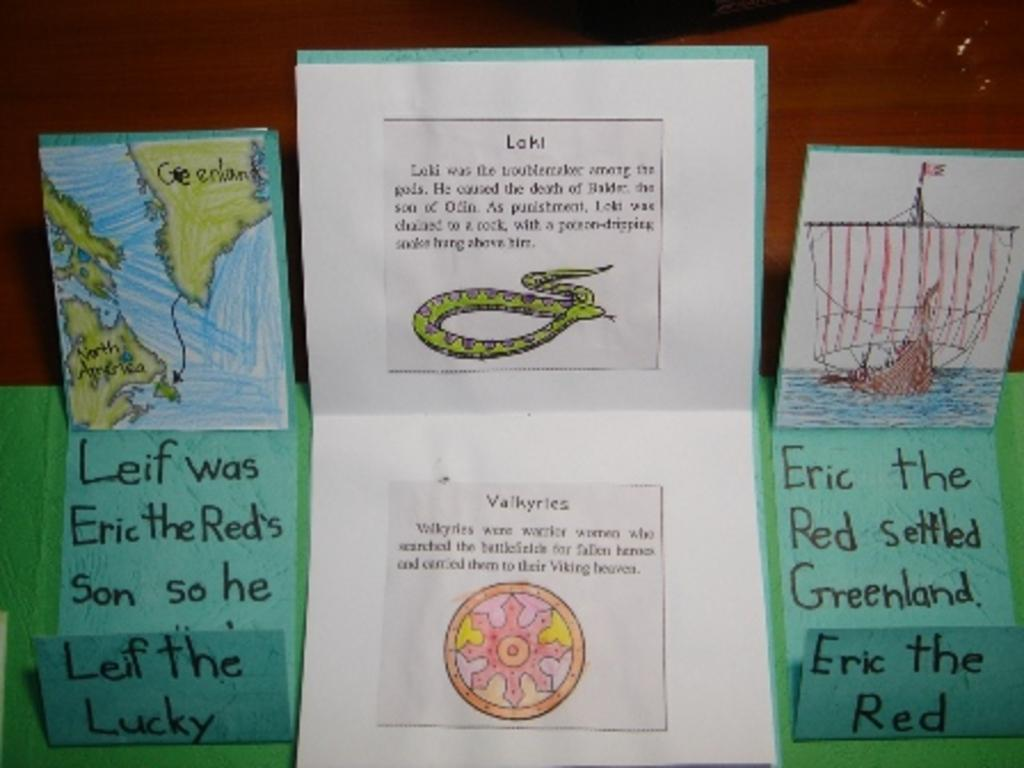What is depicted on the papers in the image? There are drawings on the papers in the image. Are there any words written on the papers? Yes, there are words written on the papers. What color is the surface on which the papers are placed? The papers are on a green color surface. What color is the background of the image? The background of the image is red. Can you tell me how many celery stalks are visible in the image? There is no celery present in the image. Is there a chessboard visible in the image? There is no chessboard present in the image. 